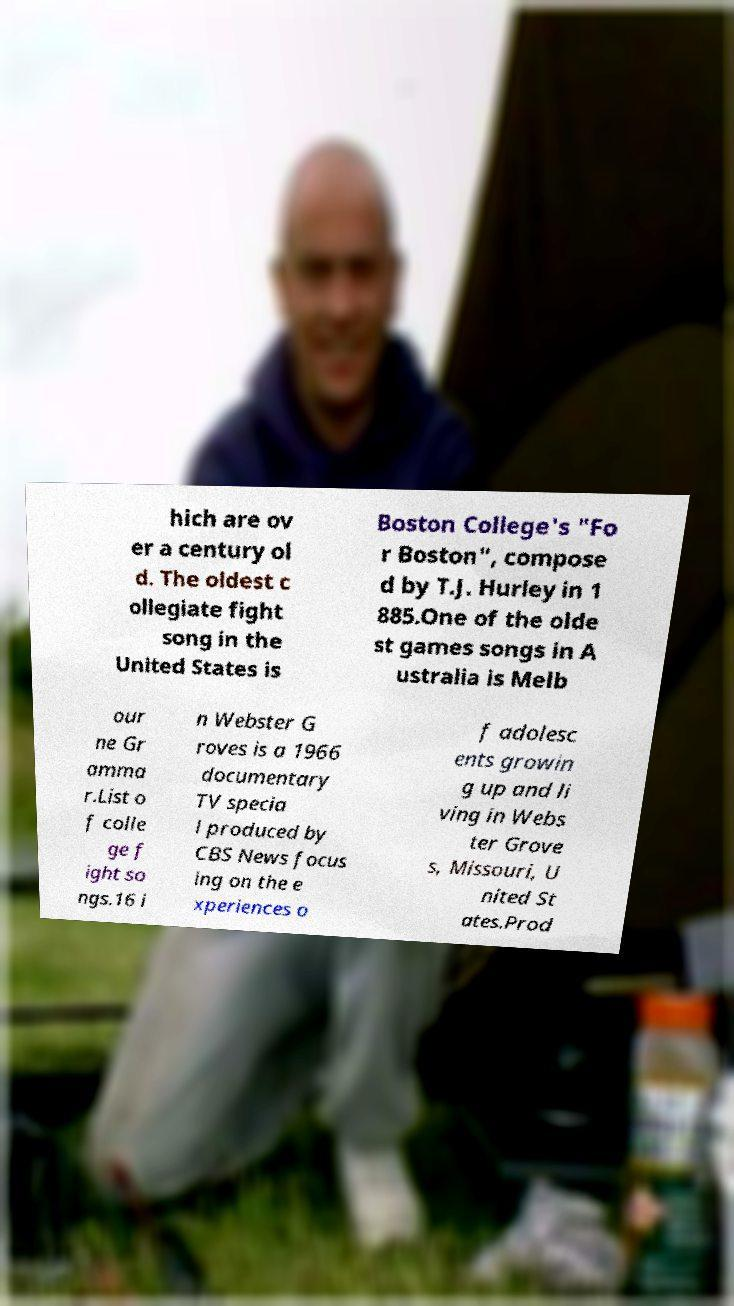Could you extract and type out the text from this image? hich are ov er a century ol d. The oldest c ollegiate fight song in the United States is Boston College's "Fo r Boston", compose d by T.J. Hurley in 1 885.One of the olde st games songs in A ustralia is Melb our ne Gr amma r.List o f colle ge f ight so ngs.16 i n Webster G roves is a 1966 documentary TV specia l produced by CBS News focus ing on the e xperiences o f adolesc ents growin g up and li ving in Webs ter Grove s, Missouri, U nited St ates.Prod 